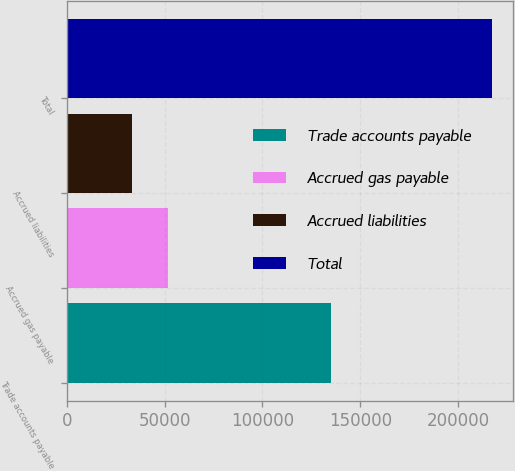Convert chart. <chart><loc_0><loc_0><loc_500><loc_500><bar_chart><fcel>Trade accounts payable<fcel>Accrued gas payable<fcel>Accrued liabilities<fcel>Total<nl><fcel>135159<fcel>51791<fcel>33403<fcel>217283<nl></chart> 